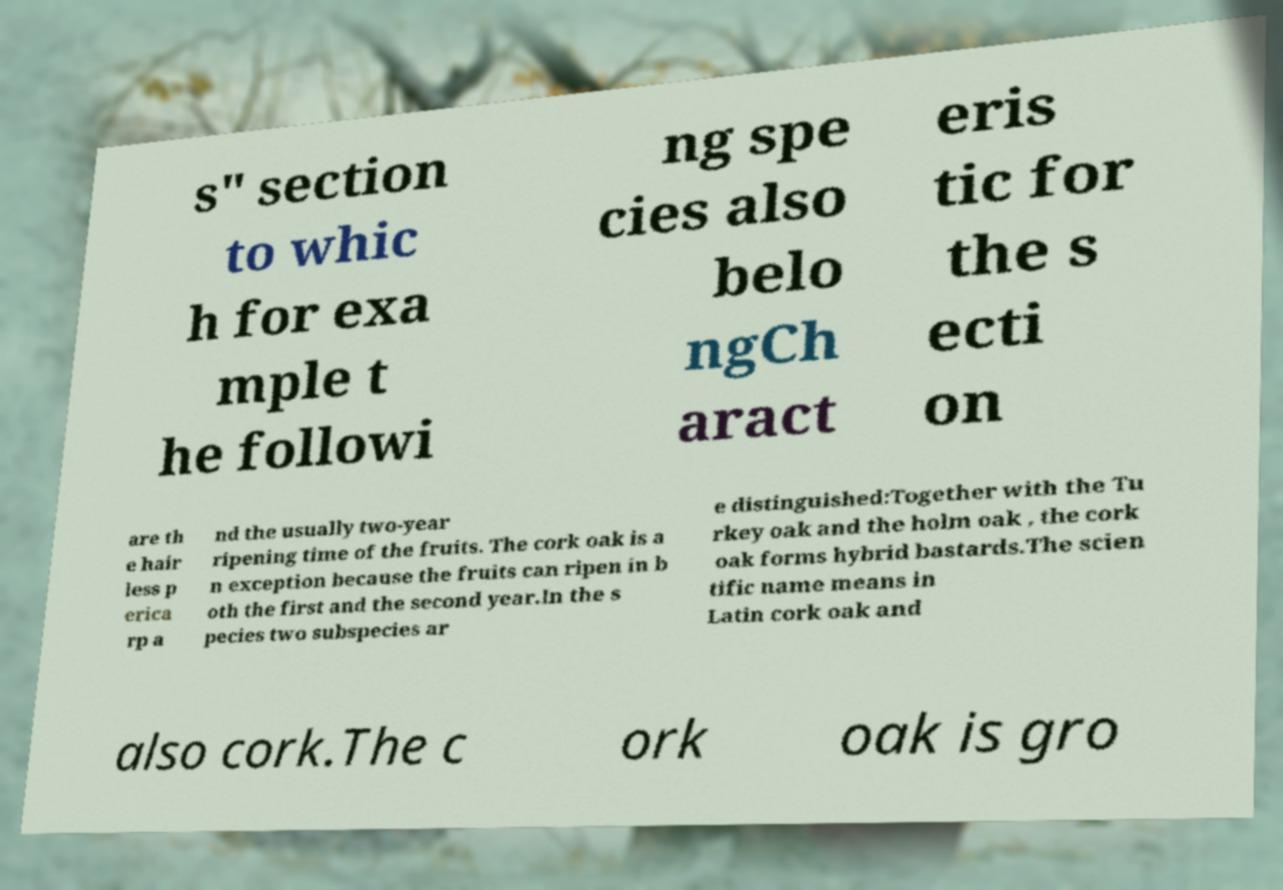I need the written content from this picture converted into text. Can you do that? s" section to whic h for exa mple t he followi ng spe cies also belo ngCh aract eris tic for the s ecti on are th e hair less p erica rp a nd the usually two-year ripening time of the fruits. The cork oak is a n exception because the fruits can ripen in b oth the first and the second year.In the s pecies two subspecies ar e distinguished:Together with the Tu rkey oak and the holm oak , the cork oak forms hybrid bastards.The scien tific name means in Latin cork oak and also cork.The c ork oak is gro 